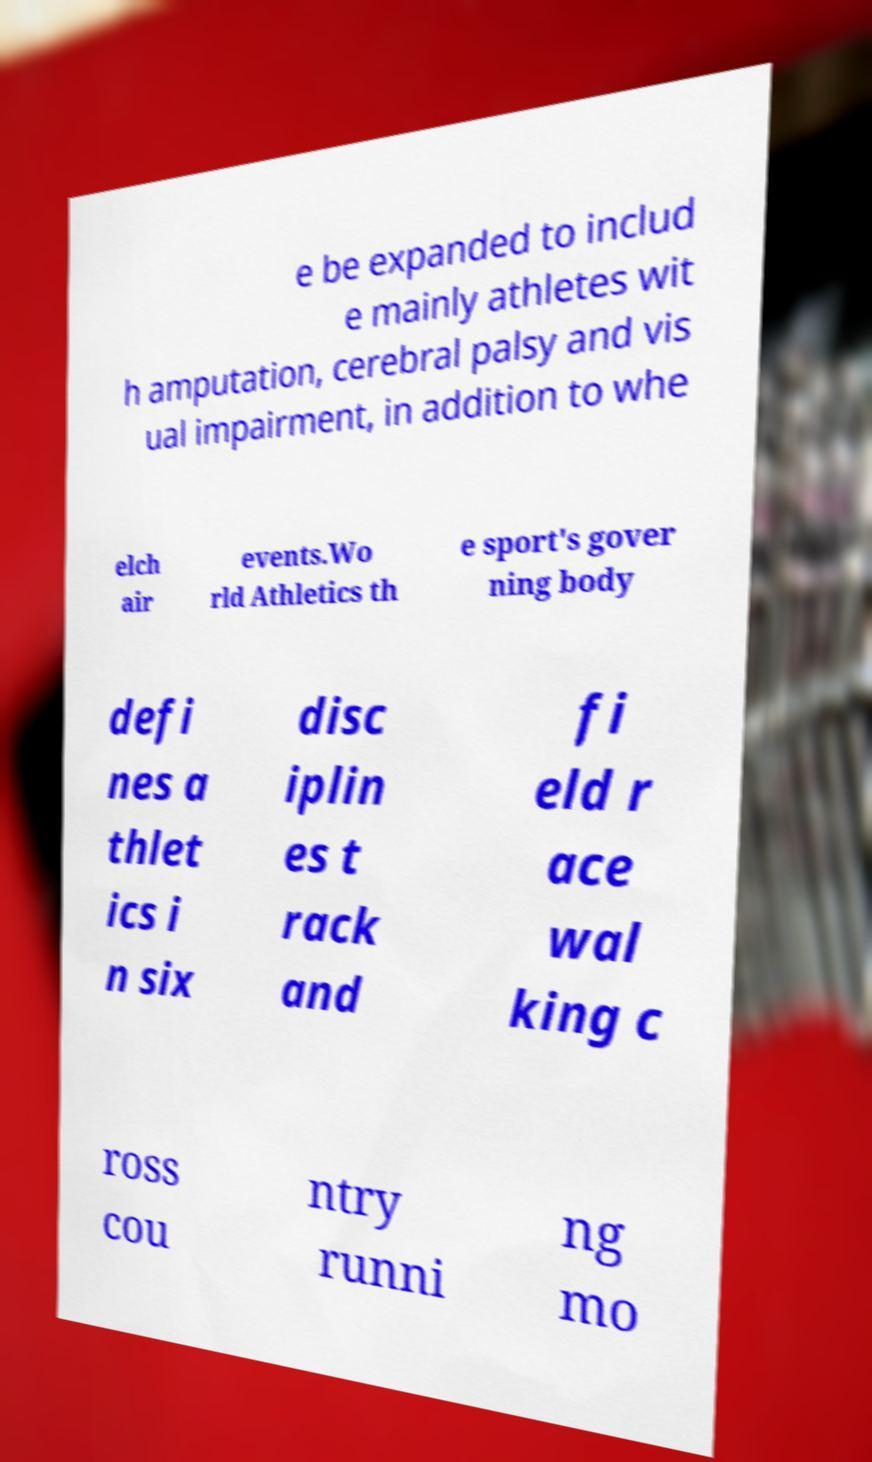There's text embedded in this image that I need extracted. Can you transcribe it verbatim? e be expanded to includ e mainly athletes wit h amputation, cerebral palsy and vis ual impairment, in addition to whe elch air events.Wo rld Athletics th e sport's gover ning body defi nes a thlet ics i n six disc iplin es t rack and fi eld r ace wal king c ross cou ntry runni ng mo 